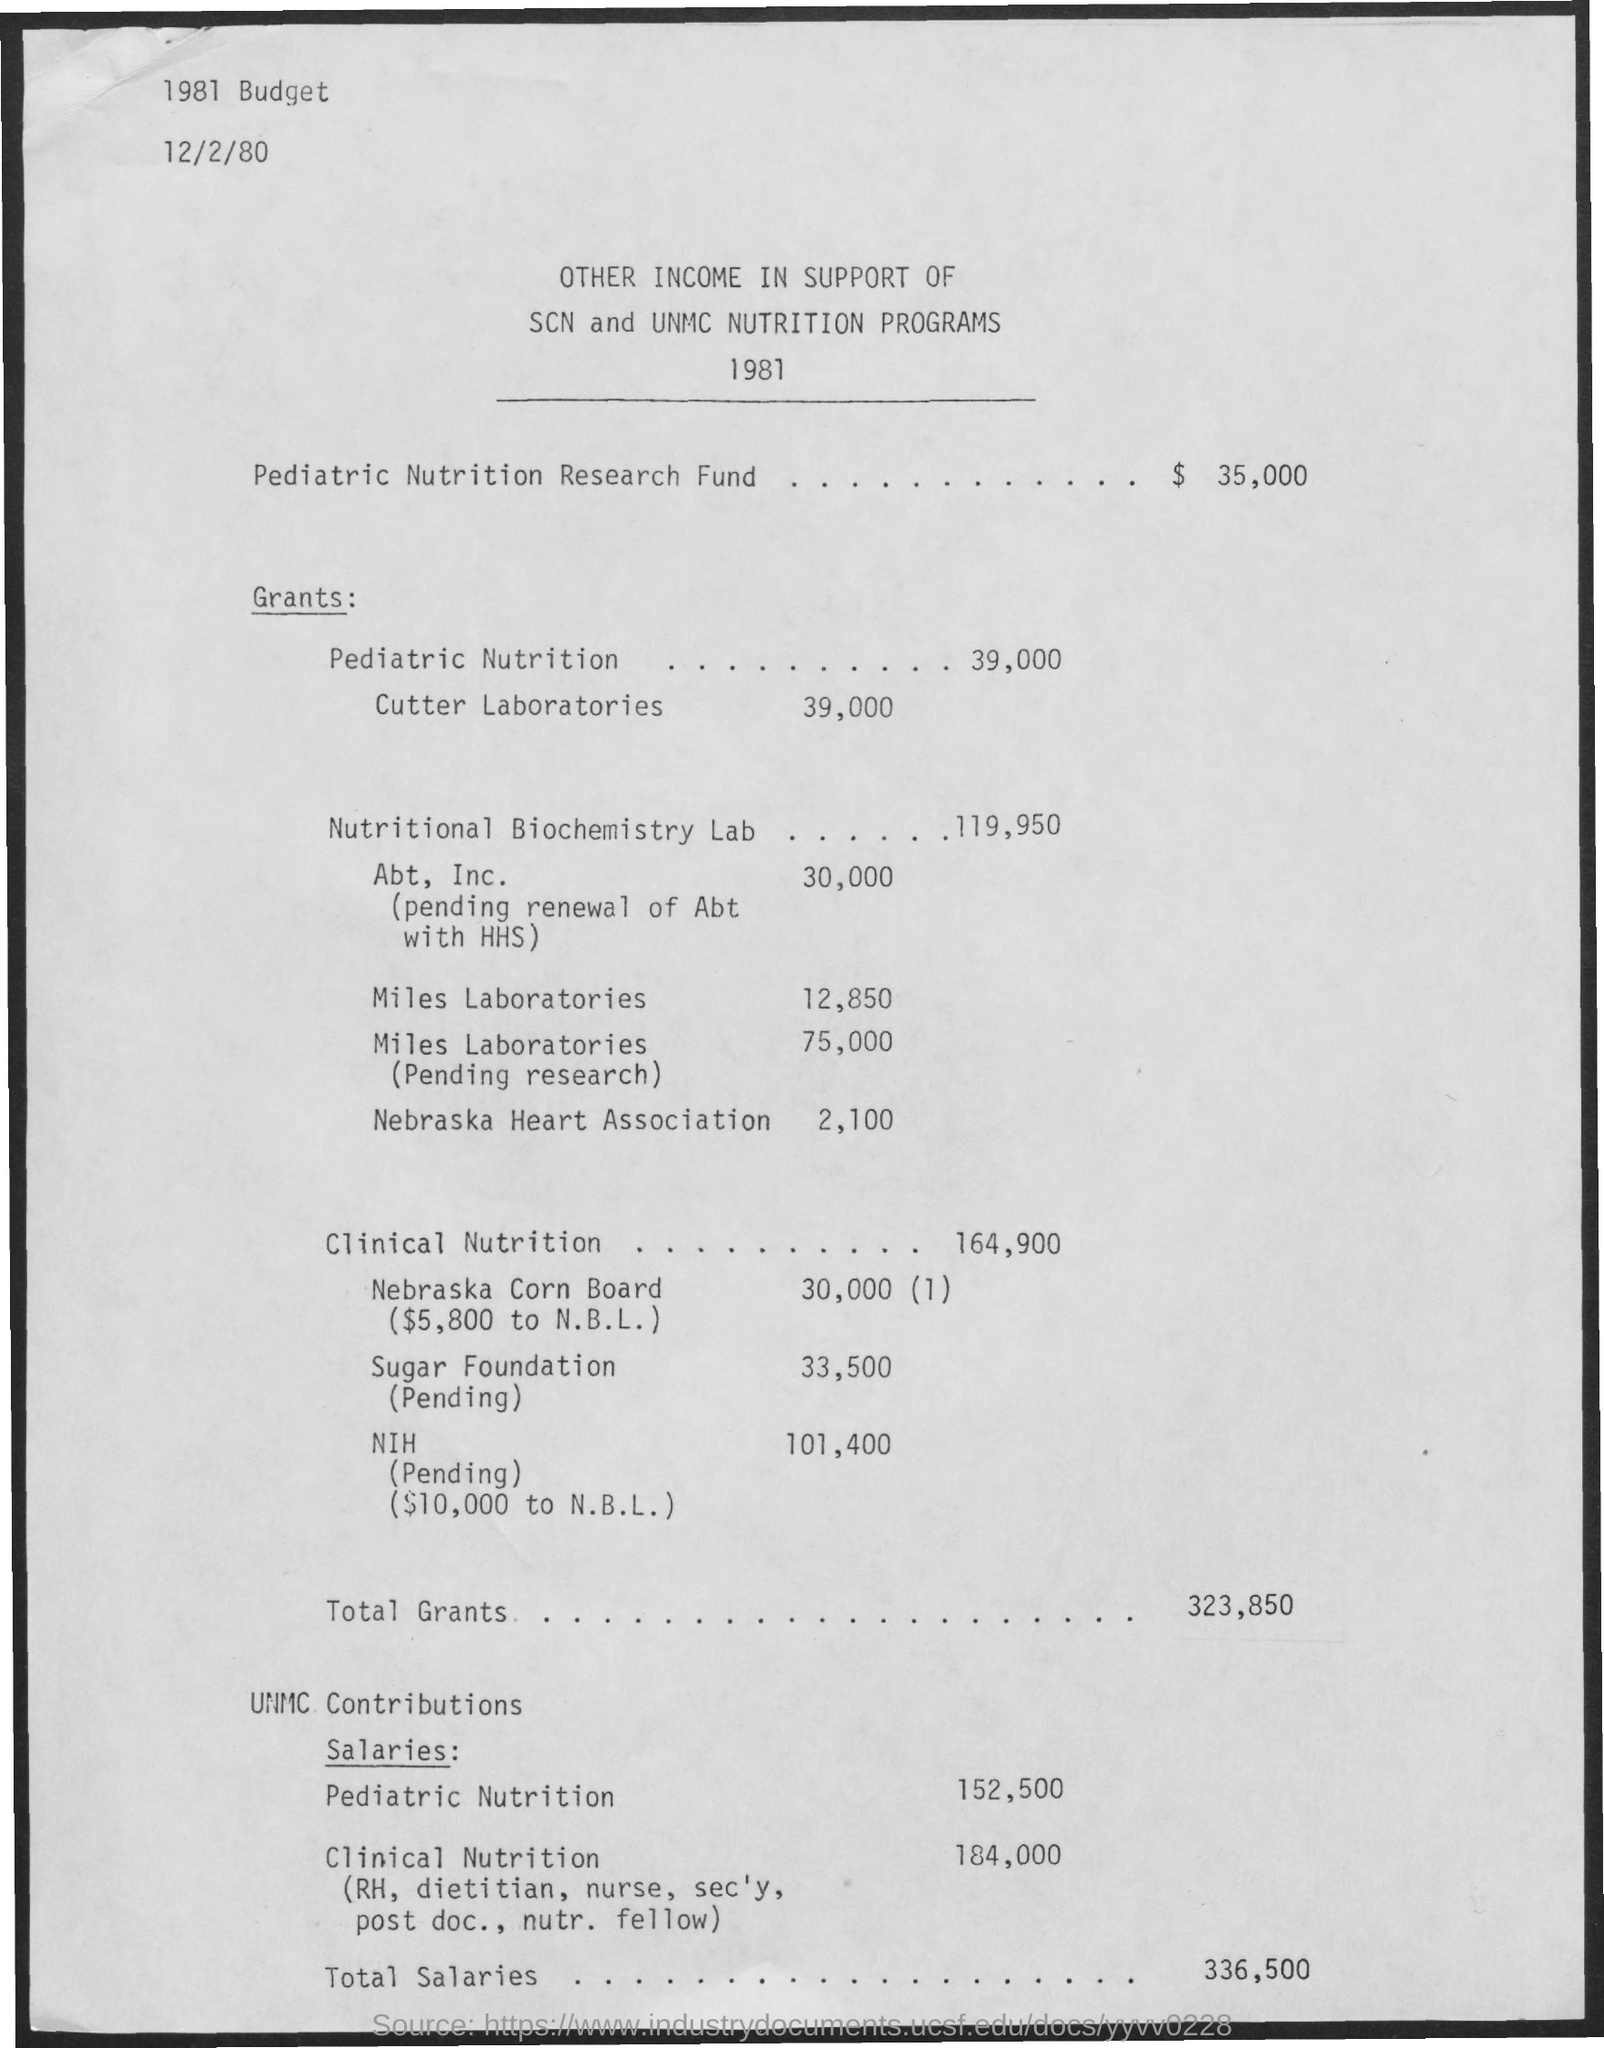What is the amount fromPediatric Nutrition research fund?
Provide a short and direct response. $35,000. What are the grants for pediatric nutrition?
Your answer should be compact. 39,000. What are the grants for cutter laboratories?
Provide a succinct answer. 39,000. What are the grants for Nutritional Biochemistry Lab?
Provide a short and direct response. 119,950. What are the grants for Abt, Inc.?
Provide a short and direct response. 30,000. What are the grants for Miles laboratories?
Make the answer very short. 12,850. What are the grants for Miles laboratories(pending research)?
Keep it short and to the point. 75,000. What are the grants for Nebraska Heart Association?
Ensure brevity in your answer.  2,100. What are the Total grants?
Your response must be concise. 323,850. 